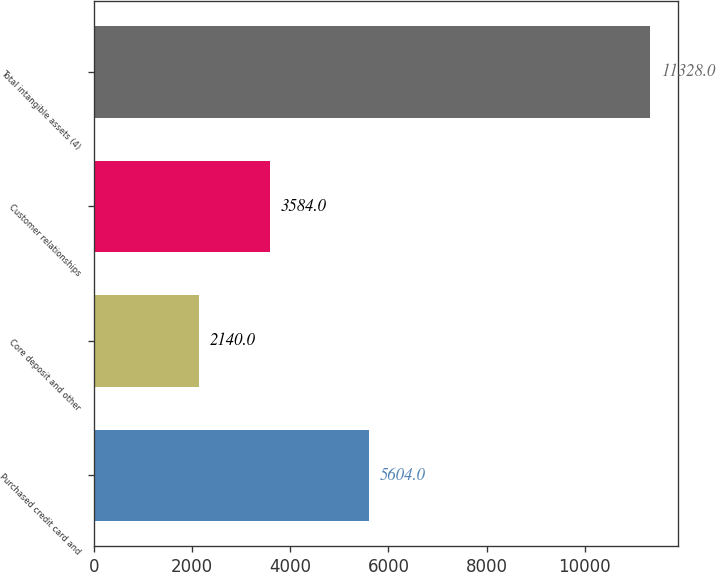<chart> <loc_0><loc_0><loc_500><loc_500><bar_chart><fcel>Purchased credit card and<fcel>Core deposit and other<fcel>Customer relationships<fcel>Total intangible assets (4)<nl><fcel>5604<fcel>2140<fcel>3584<fcel>11328<nl></chart> 